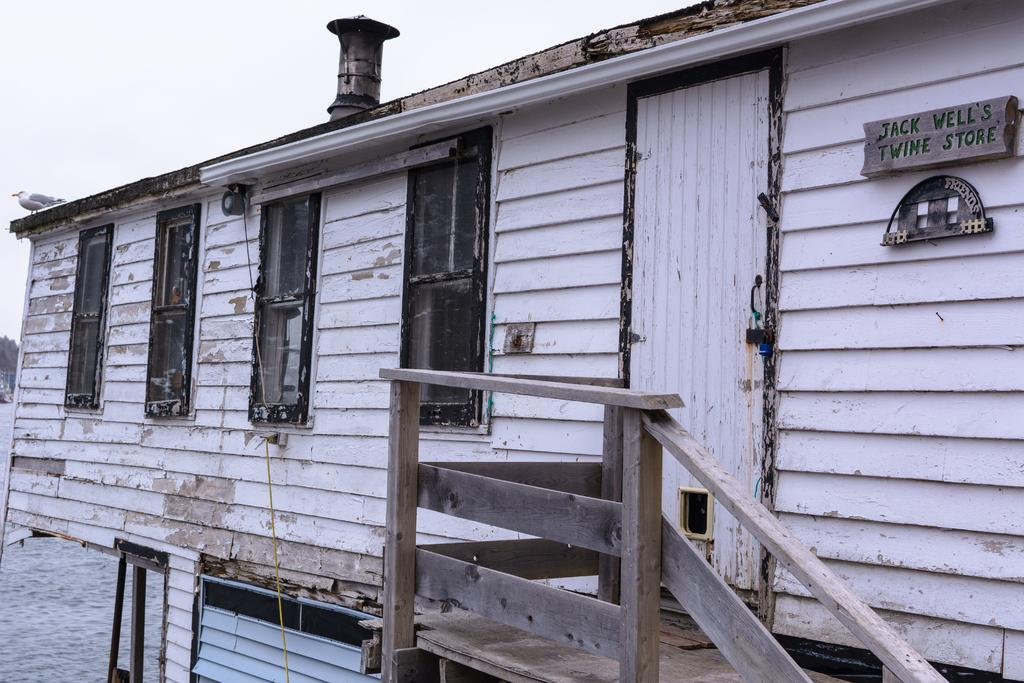What type of stairs are in the image? There are wooden stairs in the image. What kind of structure is present in the image? There is a wooden house in the image. What is attached to the wooden house? A board is visible on the wooden house. What type of animal can be seen in the image? There is a bird in the image. What is visible in the background of the image? The sky is visible in the background of the image. What is the ground condition in the image? There is snow on the ground in the image. Where is the veil located in the image? There is no veil present in the image. What type of yard is visible in the image? There is no yard visible in the image; it features a wooden house, wooden stairs, and snow on the ground. 